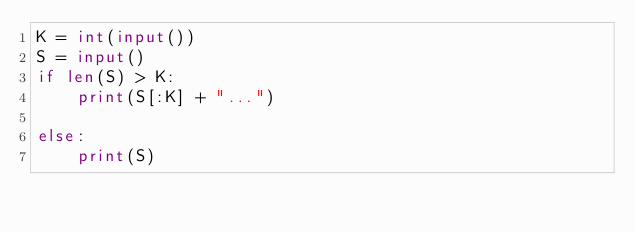<code> <loc_0><loc_0><loc_500><loc_500><_Python_>K = int(input())
S = input()
if len(S) > K:
    print(S[:K] + "...")
        
else:
    print(S)</code> 